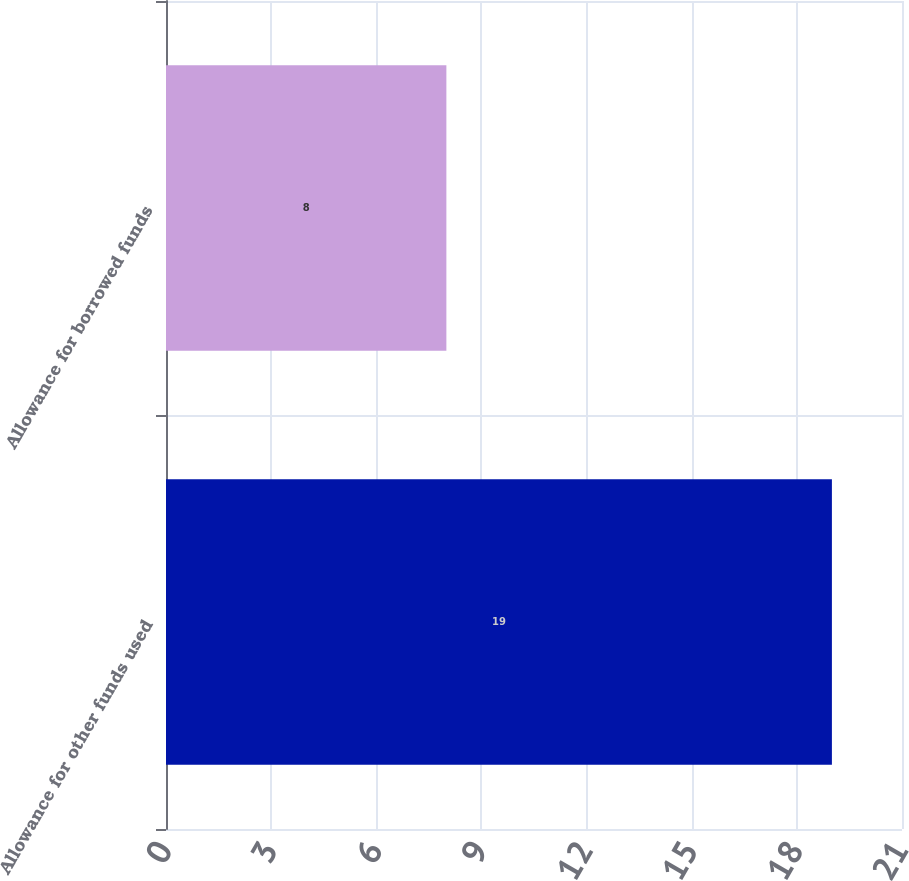Convert chart to OTSL. <chart><loc_0><loc_0><loc_500><loc_500><bar_chart><fcel>Allowance for other funds used<fcel>Allowance for borrowed funds<nl><fcel>19<fcel>8<nl></chart> 